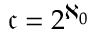Convert formula to latex. <formula><loc_0><loc_0><loc_500><loc_500>{ \mathfrak { c } } = 2 ^ { \aleph _ { 0 } }</formula> 